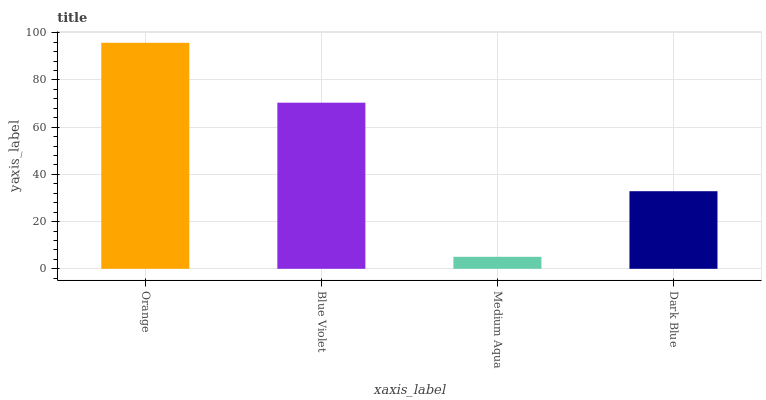Is Medium Aqua the minimum?
Answer yes or no. Yes. Is Orange the maximum?
Answer yes or no. Yes. Is Blue Violet the minimum?
Answer yes or no. No. Is Blue Violet the maximum?
Answer yes or no. No. Is Orange greater than Blue Violet?
Answer yes or no. Yes. Is Blue Violet less than Orange?
Answer yes or no. Yes. Is Blue Violet greater than Orange?
Answer yes or no. No. Is Orange less than Blue Violet?
Answer yes or no. No. Is Blue Violet the high median?
Answer yes or no. Yes. Is Dark Blue the low median?
Answer yes or no. Yes. Is Dark Blue the high median?
Answer yes or no. No. Is Medium Aqua the low median?
Answer yes or no. No. 